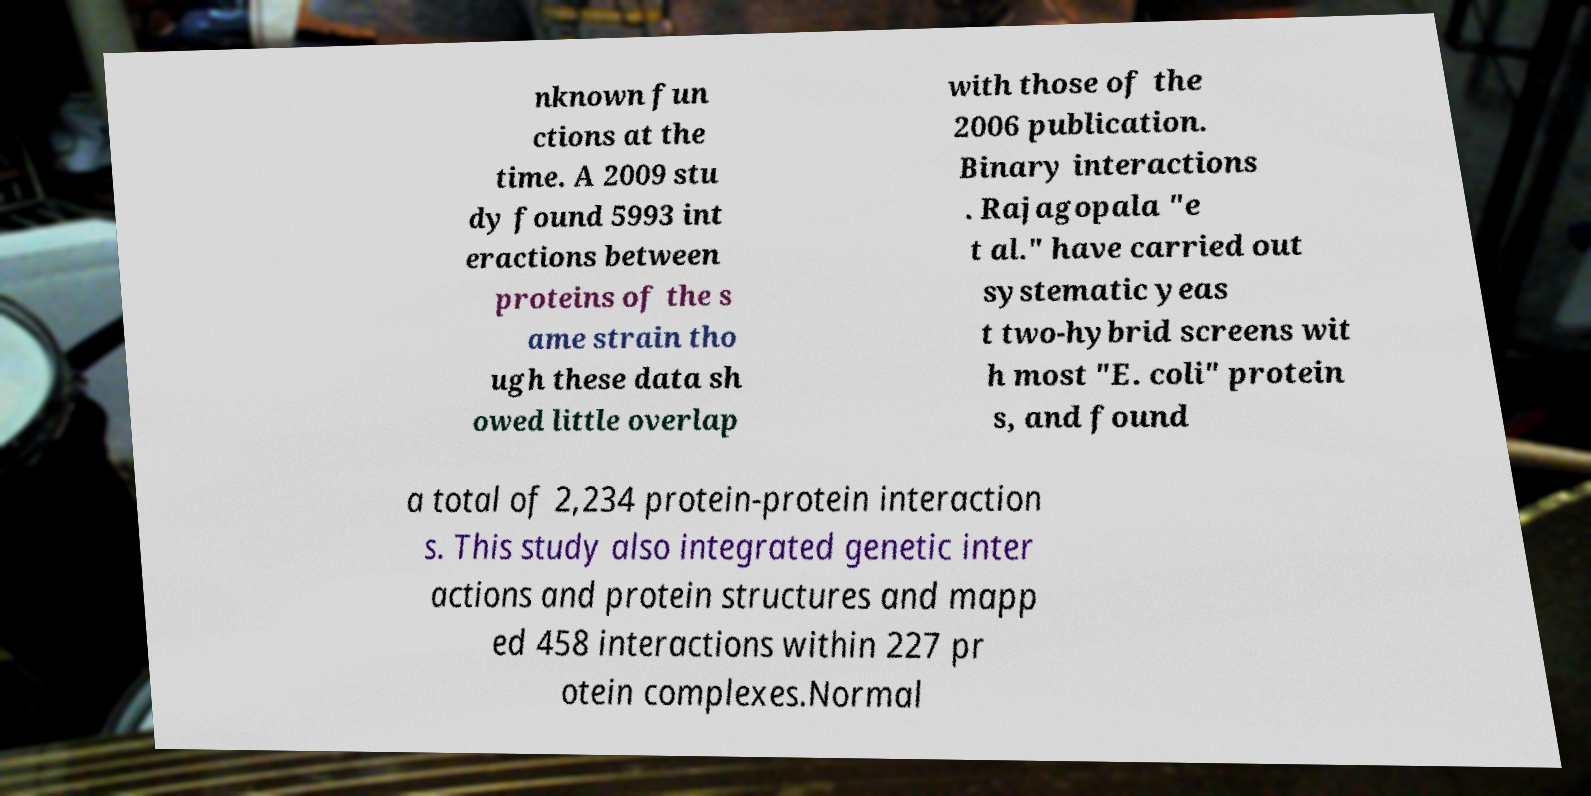Please read and relay the text visible in this image. What does it say? nknown fun ctions at the time. A 2009 stu dy found 5993 int eractions between proteins of the s ame strain tho ugh these data sh owed little overlap with those of the 2006 publication. Binary interactions . Rajagopala "e t al." have carried out systematic yeas t two-hybrid screens wit h most "E. coli" protein s, and found a total of 2,234 protein-protein interaction s. This study also integrated genetic inter actions and protein structures and mapp ed 458 interactions within 227 pr otein complexes.Normal 